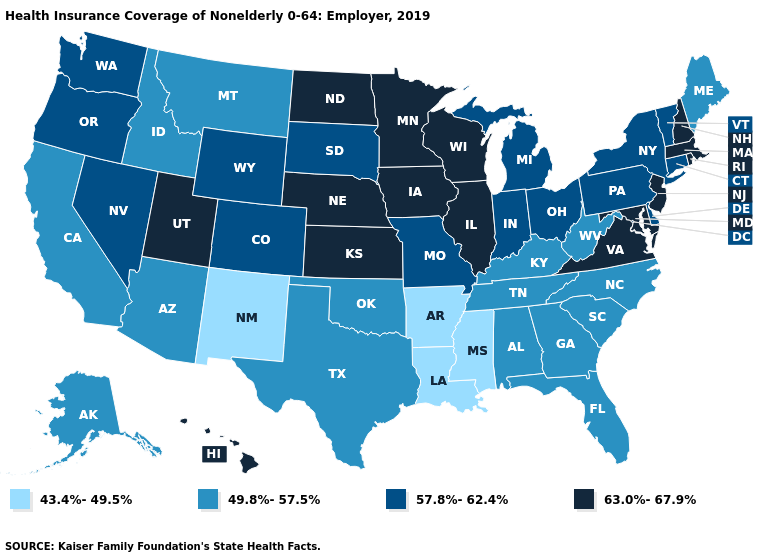Name the states that have a value in the range 57.8%-62.4%?
Quick response, please. Colorado, Connecticut, Delaware, Indiana, Michigan, Missouri, Nevada, New York, Ohio, Oregon, Pennsylvania, South Dakota, Vermont, Washington, Wyoming. Does North Dakota have a lower value than Michigan?
Concise answer only. No. Does Massachusetts have the highest value in the Northeast?
Concise answer only. Yes. What is the highest value in the USA?
Write a very short answer. 63.0%-67.9%. What is the lowest value in states that border North Carolina?
Answer briefly. 49.8%-57.5%. Name the states that have a value in the range 57.8%-62.4%?
Give a very brief answer. Colorado, Connecticut, Delaware, Indiana, Michigan, Missouri, Nevada, New York, Ohio, Oregon, Pennsylvania, South Dakota, Vermont, Washington, Wyoming. Among the states that border Nebraska , does Iowa have the highest value?
Give a very brief answer. Yes. Name the states that have a value in the range 57.8%-62.4%?
Quick response, please. Colorado, Connecticut, Delaware, Indiana, Michigan, Missouri, Nevada, New York, Ohio, Oregon, Pennsylvania, South Dakota, Vermont, Washington, Wyoming. Does Virginia have the highest value in the USA?
Give a very brief answer. Yes. What is the value of Maryland?
Be succinct. 63.0%-67.9%. Which states have the highest value in the USA?
Concise answer only. Hawaii, Illinois, Iowa, Kansas, Maryland, Massachusetts, Minnesota, Nebraska, New Hampshire, New Jersey, North Dakota, Rhode Island, Utah, Virginia, Wisconsin. Does Washington have a higher value than New Hampshire?
Quick response, please. No. Which states have the highest value in the USA?
Concise answer only. Hawaii, Illinois, Iowa, Kansas, Maryland, Massachusetts, Minnesota, Nebraska, New Hampshire, New Jersey, North Dakota, Rhode Island, Utah, Virginia, Wisconsin. What is the value of Alaska?
Short answer required. 49.8%-57.5%. Name the states that have a value in the range 49.8%-57.5%?
Be succinct. Alabama, Alaska, Arizona, California, Florida, Georgia, Idaho, Kentucky, Maine, Montana, North Carolina, Oklahoma, South Carolina, Tennessee, Texas, West Virginia. 